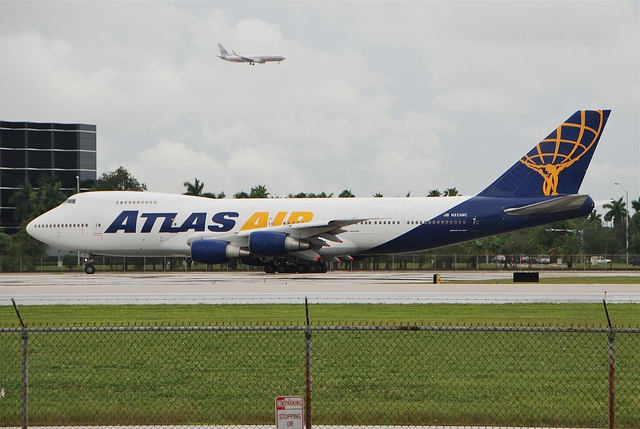Describe the objects in this image and their specific colors. I can see airplane in lightgray, black, navy, and darkgray tones, airplane in lightgray, darkgray, and gray tones, car in lightgray, gray, black, and darkgray tones, car in lightgray, black, gray, and darkgray tones, and car in lightgray, gray, darkgray, and black tones in this image. 